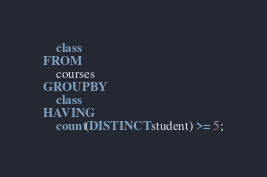<code> <loc_0><loc_0><loc_500><loc_500><_SQL_>    class
FROM
    courses
GROUP BY
    class
HAVING
    count(DISTINCT student) >= 5;
</code> 